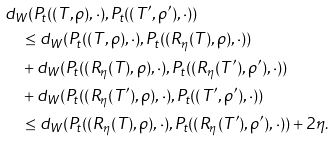<formula> <loc_0><loc_0><loc_500><loc_500>& d _ { W } ( { P } _ { t } ( ( T , \rho ) , \cdot ) , { P } _ { t } ( ( T ^ { \prime } , \rho ^ { \prime } ) , \cdot ) ) \\ & \quad \leq d _ { W } ( { P } _ { t } ( ( T , \rho ) , \cdot ) , { P } _ { t } ( ( R _ { \eta } ( T ) , \rho ) , \cdot ) ) \\ & \quad + d _ { W } ( { P } _ { t } ( ( R _ { \eta } ( T ) , \rho ) , \cdot ) , { P } _ { t } ( ( R _ { \eta } ( T ^ { \prime } ) , \rho ^ { \prime } ) , \cdot ) ) \\ & \quad + d _ { W } ( { P } _ { t } ( ( R _ { \eta } ( T ^ { \prime } ) , \rho ) , \cdot ) , { P } _ { t } ( ( T ^ { \prime } , \rho ^ { \prime } ) , \cdot ) ) \\ & \quad \leq d _ { W } ( { P } _ { t } ( ( R _ { \eta } ( T ) , \rho ) , \cdot ) , { P } _ { t } ( ( R _ { \eta } ( T ^ { \prime } ) , \rho ^ { \prime } ) , \cdot ) ) + 2 \eta . \\</formula> 